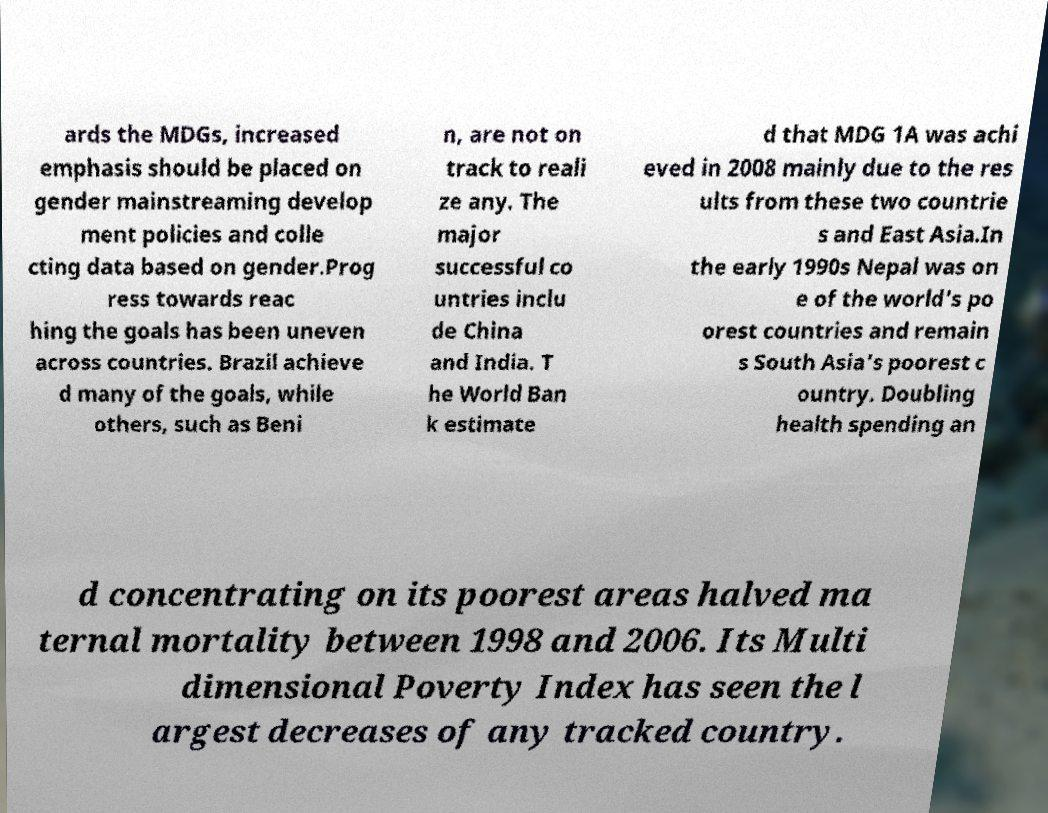I need the written content from this picture converted into text. Can you do that? ards the MDGs, increased emphasis should be placed on gender mainstreaming develop ment policies and colle cting data based on gender.Prog ress towards reac hing the goals has been uneven across countries. Brazil achieve d many of the goals, while others, such as Beni n, are not on track to reali ze any. The major successful co untries inclu de China and India. T he World Ban k estimate d that MDG 1A was achi eved in 2008 mainly due to the res ults from these two countrie s and East Asia.In the early 1990s Nepal was on e of the world's po orest countries and remain s South Asia's poorest c ountry. Doubling health spending an d concentrating on its poorest areas halved ma ternal mortality between 1998 and 2006. Its Multi dimensional Poverty Index has seen the l argest decreases of any tracked country. 